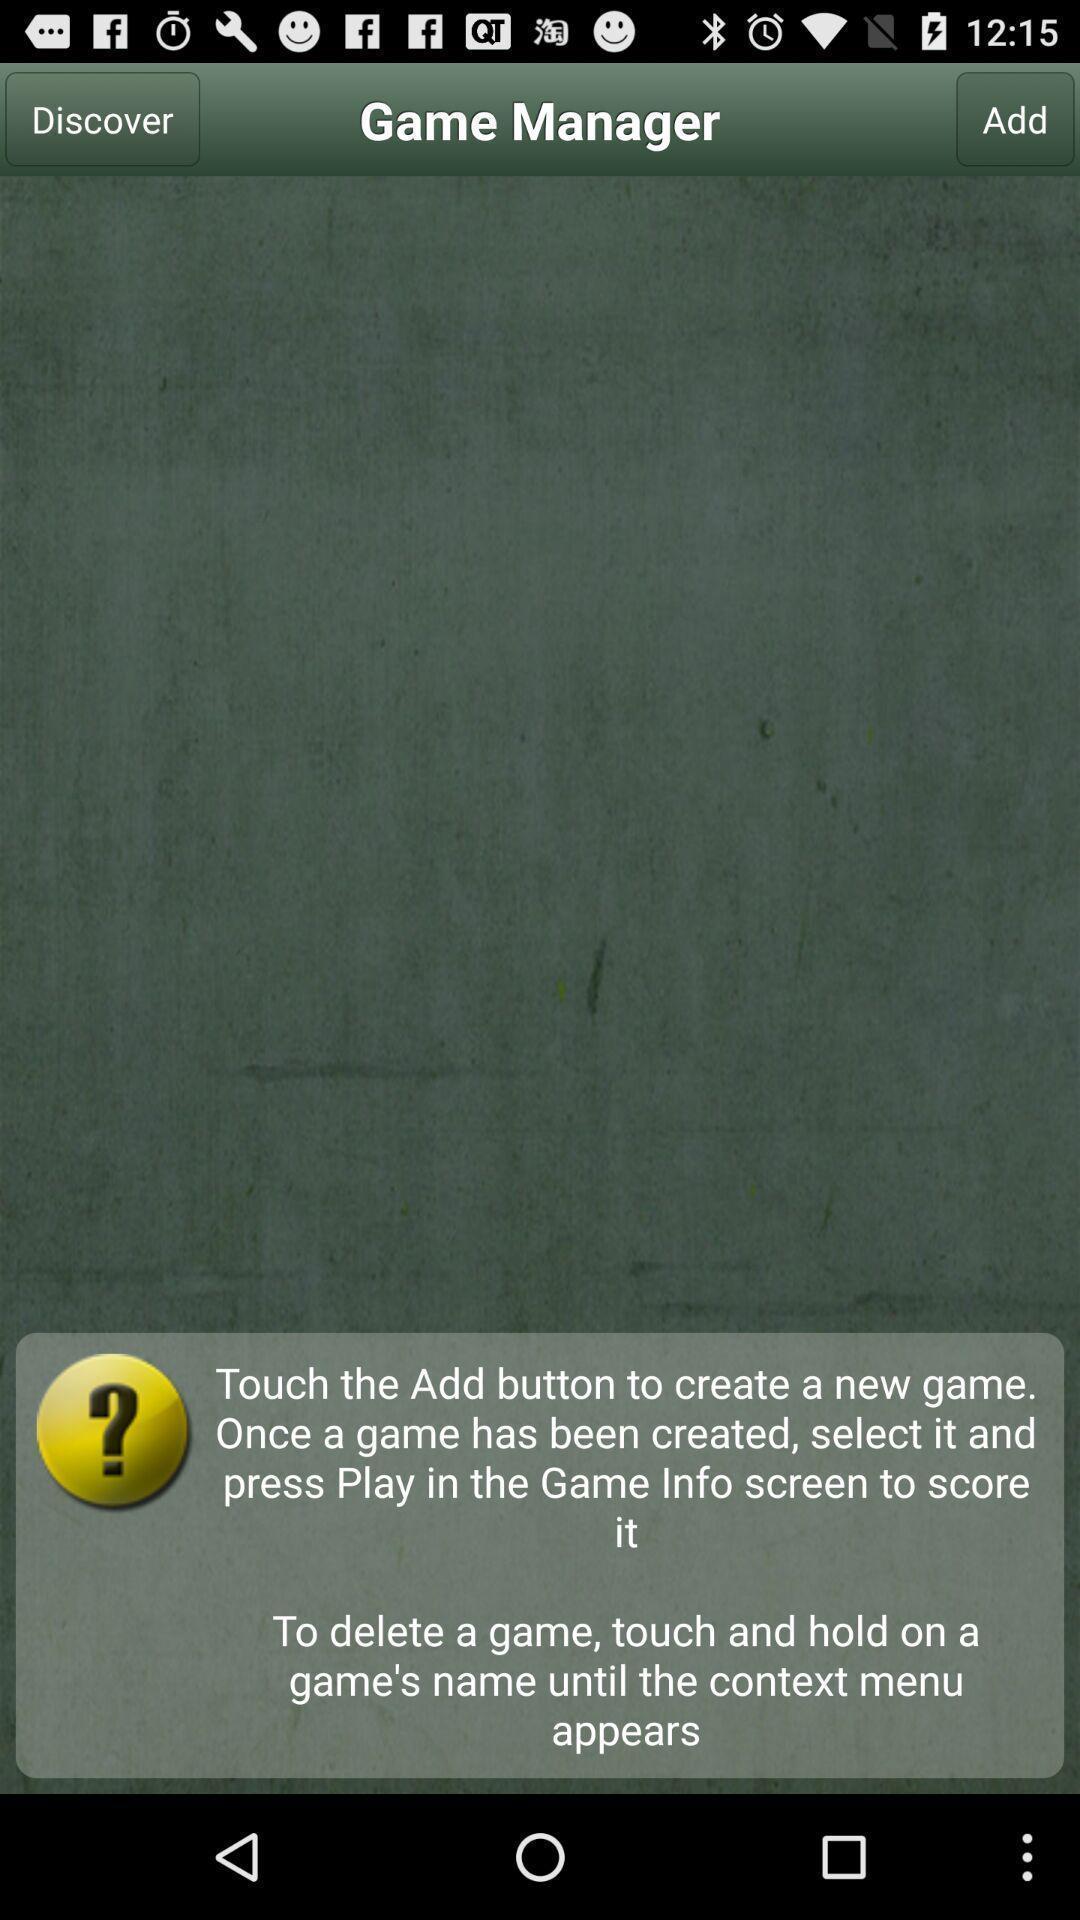Describe the key features of this screenshot. Screen shows game manager page in baseball application. 